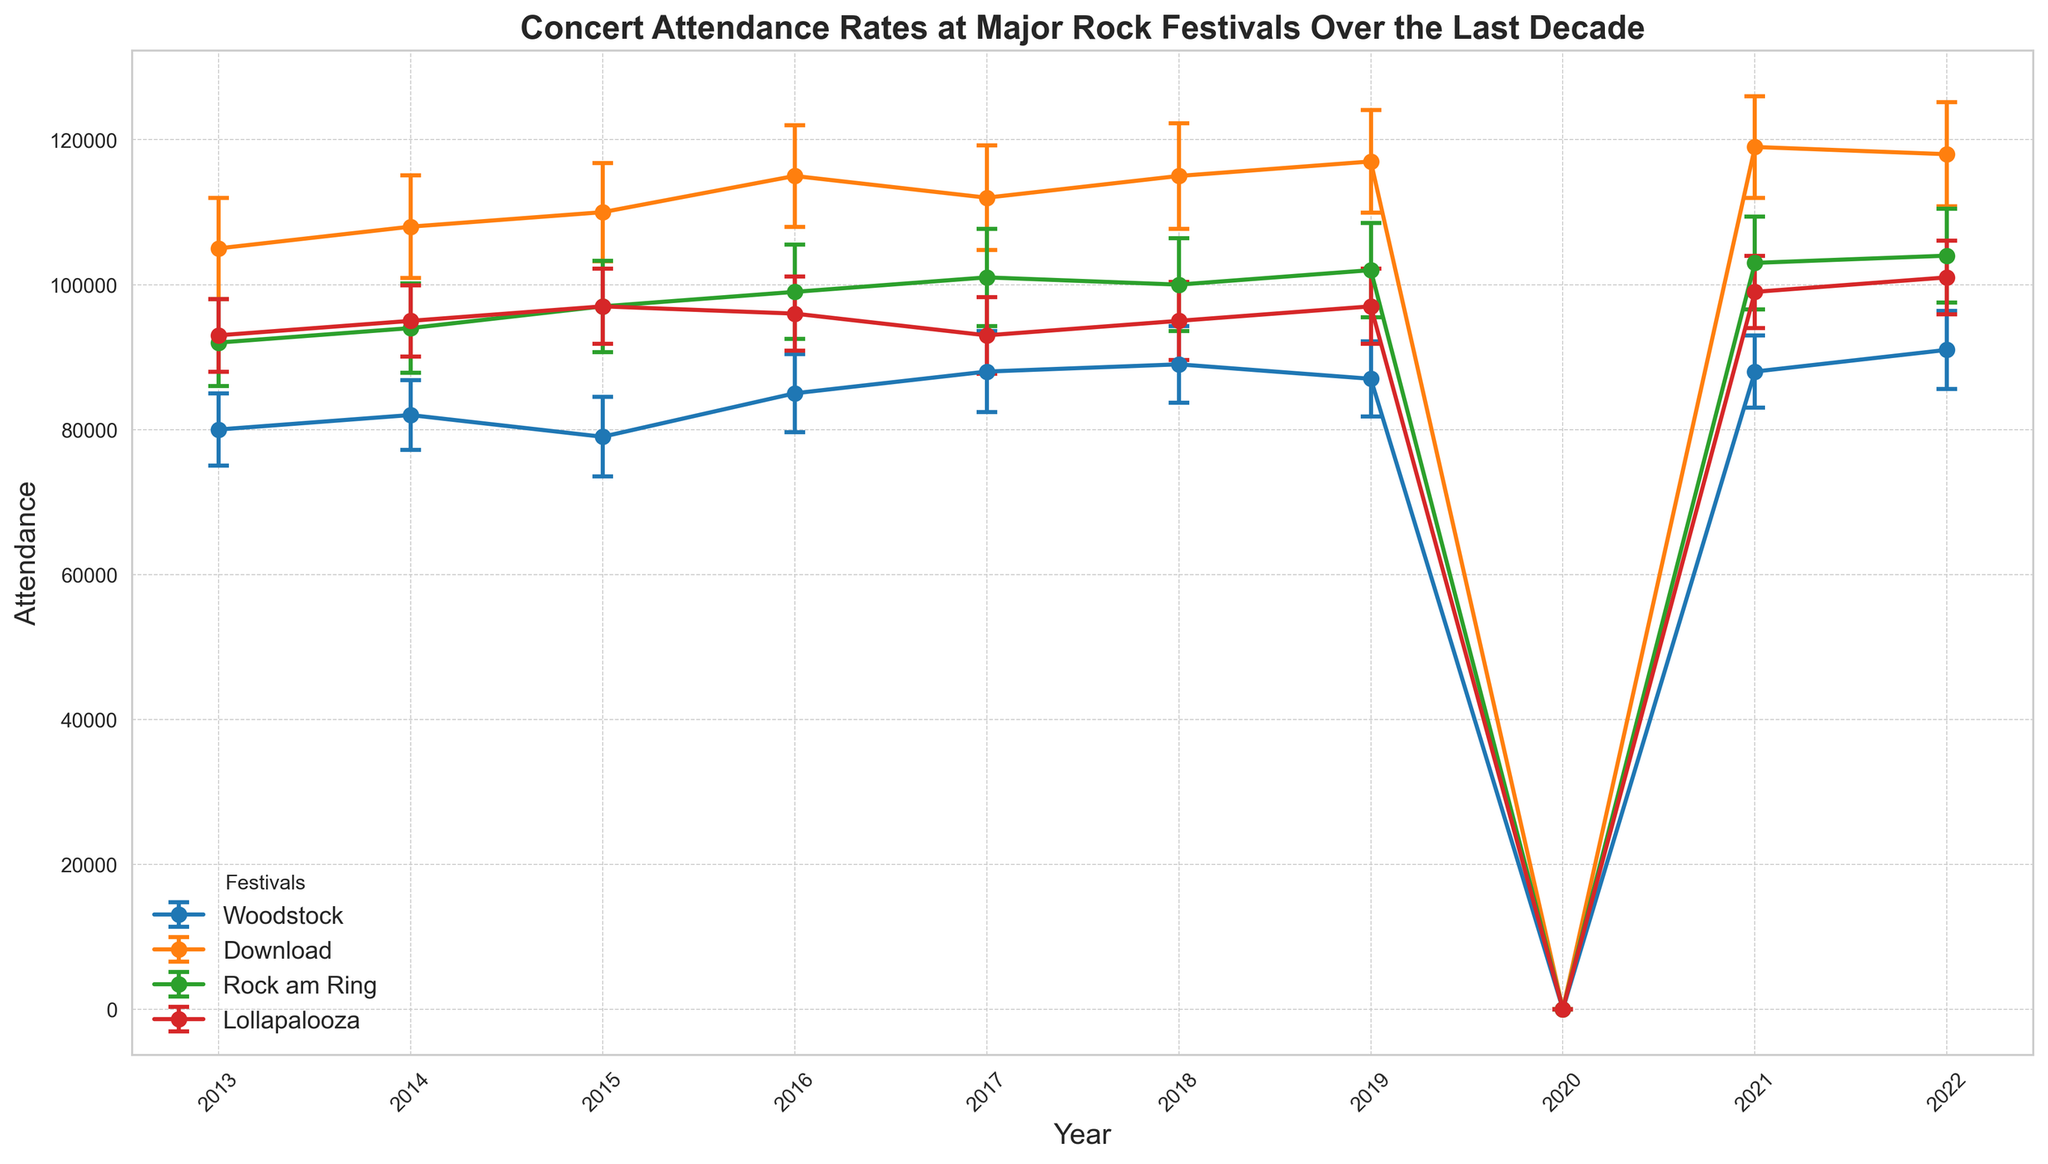What's the average attendance for Woodstock from 2013 to 2022, excluding 2020? To find the average attendance, sum up all attendance values for Woodstock from 2013 to 2022 (excluding 2020 when the festival was not held) and then divide by the number of years (9). (80000 + 82000 + 79000 + 85000 + 88000 + 89000 + 87000 + 88000 + 91000) = 759000. Dividing by 9 gives (759000 / 9) = 84333.33
Answer: 84333.33 Which festival had the highest average attendance over the decade? First, calculate the average attendance for each festival by summing their attendance over the decade (excluding 2020) and dividing by 9. Woodstock: 84333.33, Download: 113222.22, Rock am Ring: 97333.33, Lollapalooza: 95666.67. Compare these values; Download has the highest average.
Answer: Download Which year had the lowest overall attendance across all festivals? Sum the attendance for each year and compare. 2020 is excluded since the attendance was 0. Sum of attendance values: 2013: 370000, 2014: 379000, 2015: 386000, 2016: 395000, 2017: 394000, 2018: 399000, 2019: 403000, 2021: 409000, 2022: 414000. 2013 has the lowest sum.
Answer: 2013 How did the variability in attendance for Download in 2017 compare to 2018? Was it higher or lower? For each year, check the attendance error bars for Download. 2017: 7200, 2018: 7300. Thus, variability was lower in 2017.
Answer: Lower What is the trend in attendance for Rock am Ring from 2013 to 2022, excluding 2020? Observe the trend in Rock am Ring's attendance values: 92000, 94000, 97000, 99000, 101000, 100000, 102000, 103000, 104000. Attendance generally increases over time.
Answer: Increasing Among all festivals, which one showed the smallest percentage decrease in attendance from 2019 to 2021, excluding 2020? Calculate the percentage decrease for each festival: Woodstock: ((87000 - 88000) / 87000) * 100 = -1.15%, Download: ((117000 - 119000) / 117000) * 100 = -1.71%, Rock am Ring: ((102000 - 103000) / 102000) * 100 = -0.98%, Lollapalooza: ((97000 - 99000) / 97000) * 100 = -2.06%. Rock am Ring had the smallest percentage decrease.
Answer: Rock am Ring Which festival had the highest attendance error in any year, and in which year did it occur? Compare the attendance errors for each festival across all years: the highest error is 7300 for Download in 2018.
Answer: Download, 2018 How many festivals had an attendance above 100,000 in 2019? Compare attendance values for 2019: Woodstock (87000), Download (117000), Rock am Ring (102000), Lollapalooza (97000). Only Download and Rock am Ring had above 100,000 attendees.
Answer: 2 